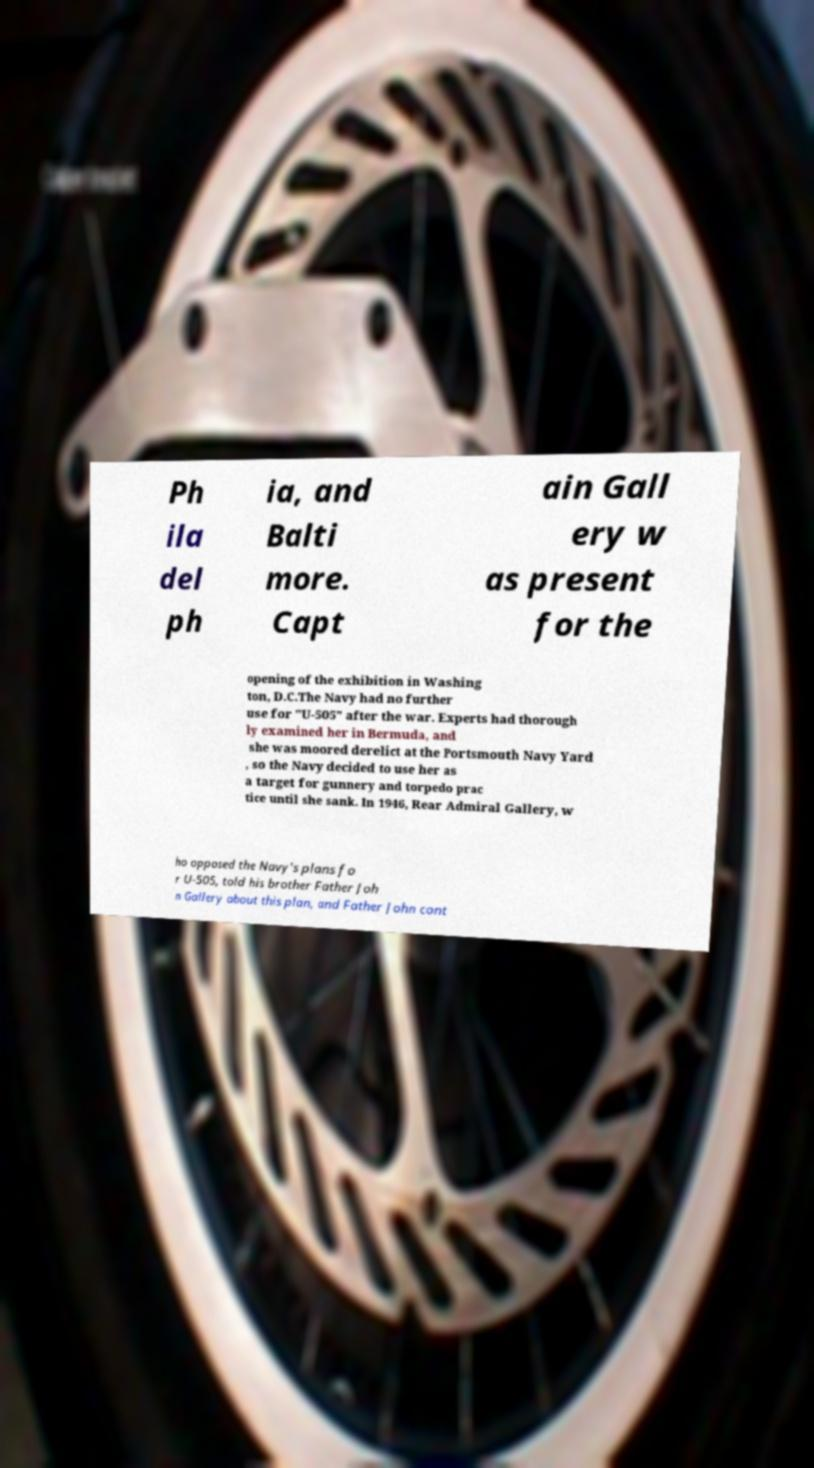There's text embedded in this image that I need extracted. Can you transcribe it verbatim? Ph ila del ph ia, and Balti more. Capt ain Gall ery w as present for the opening of the exhibition in Washing ton, D.C.The Navy had no further use for "U-505" after the war. Experts had thorough ly examined her in Bermuda, and she was moored derelict at the Portsmouth Navy Yard , so the Navy decided to use her as a target for gunnery and torpedo prac tice until she sank. In 1946, Rear Admiral Gallery, w ho opposed the Navy's plans fo r U-505, told his brother Father Joh n Gallery about this plan, and Father John cont 